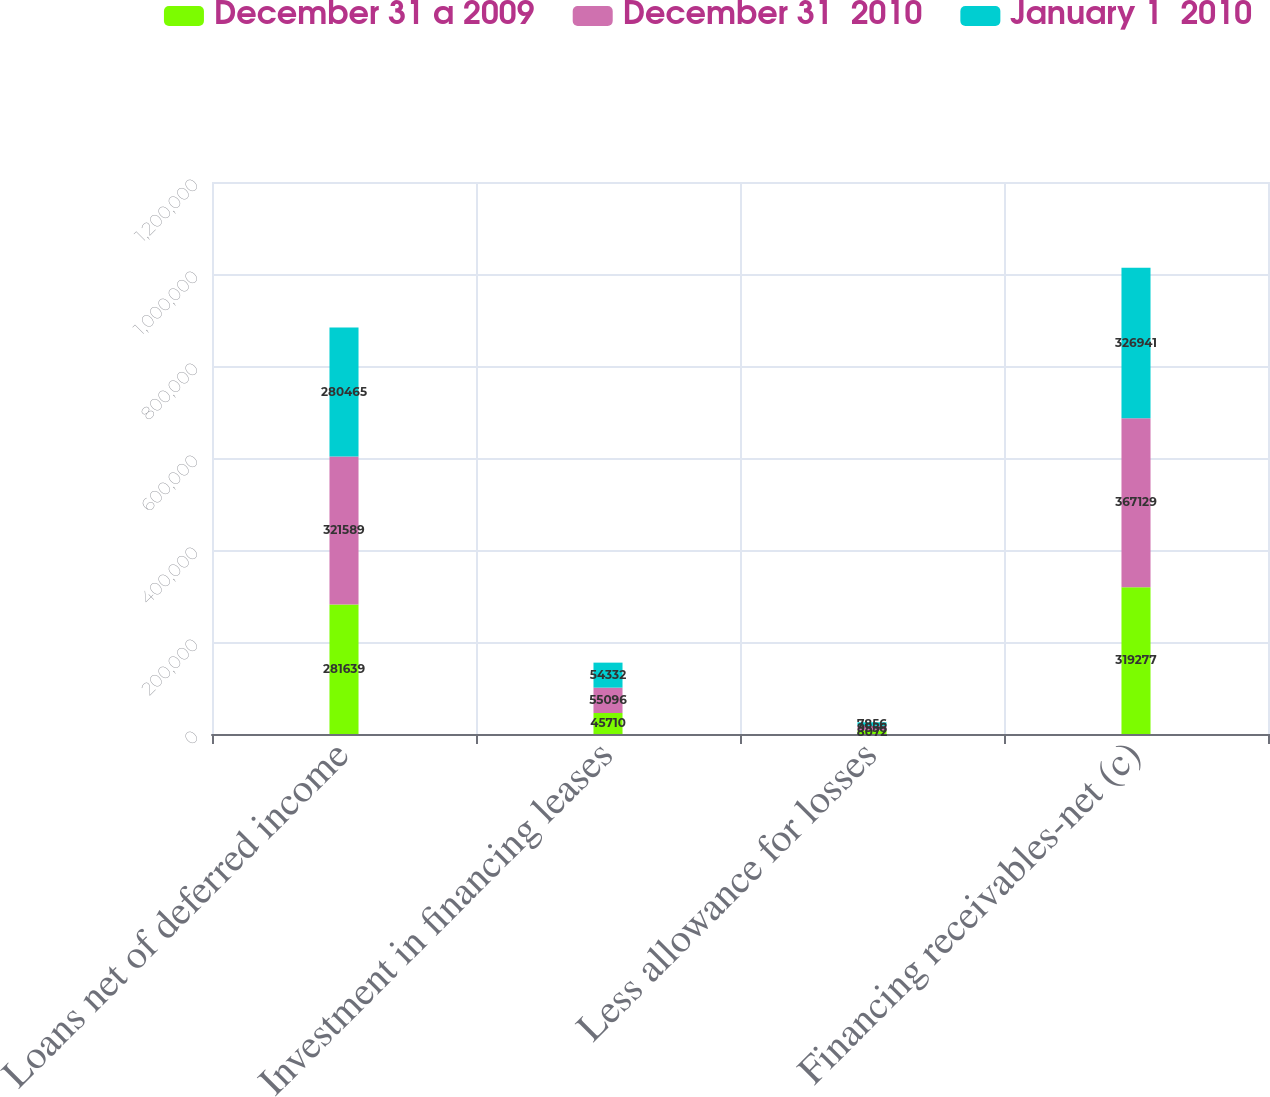Convert chart. <chart><loc_0><loc_0><loc_500><loc_500><stacked_bar_chart><ecel><fcel>Loans net of deferred income<fcel>Investment in financing leases<fcel>Less allowance for losses<fcel>Financing receivables-net (c)<nl><fcel>December 31 a 2009<fcel>281639<fcel>45710<fcel>8072<fcel>319277<nl><fcel>December 31  2010<fcel>321589<fcel>55096<fcel>9556<fcel>367129<nl><fcel>January 1  2010<fcel>280465<fcel>54332<fcel>7856<fcel>326941<nl></chart> 